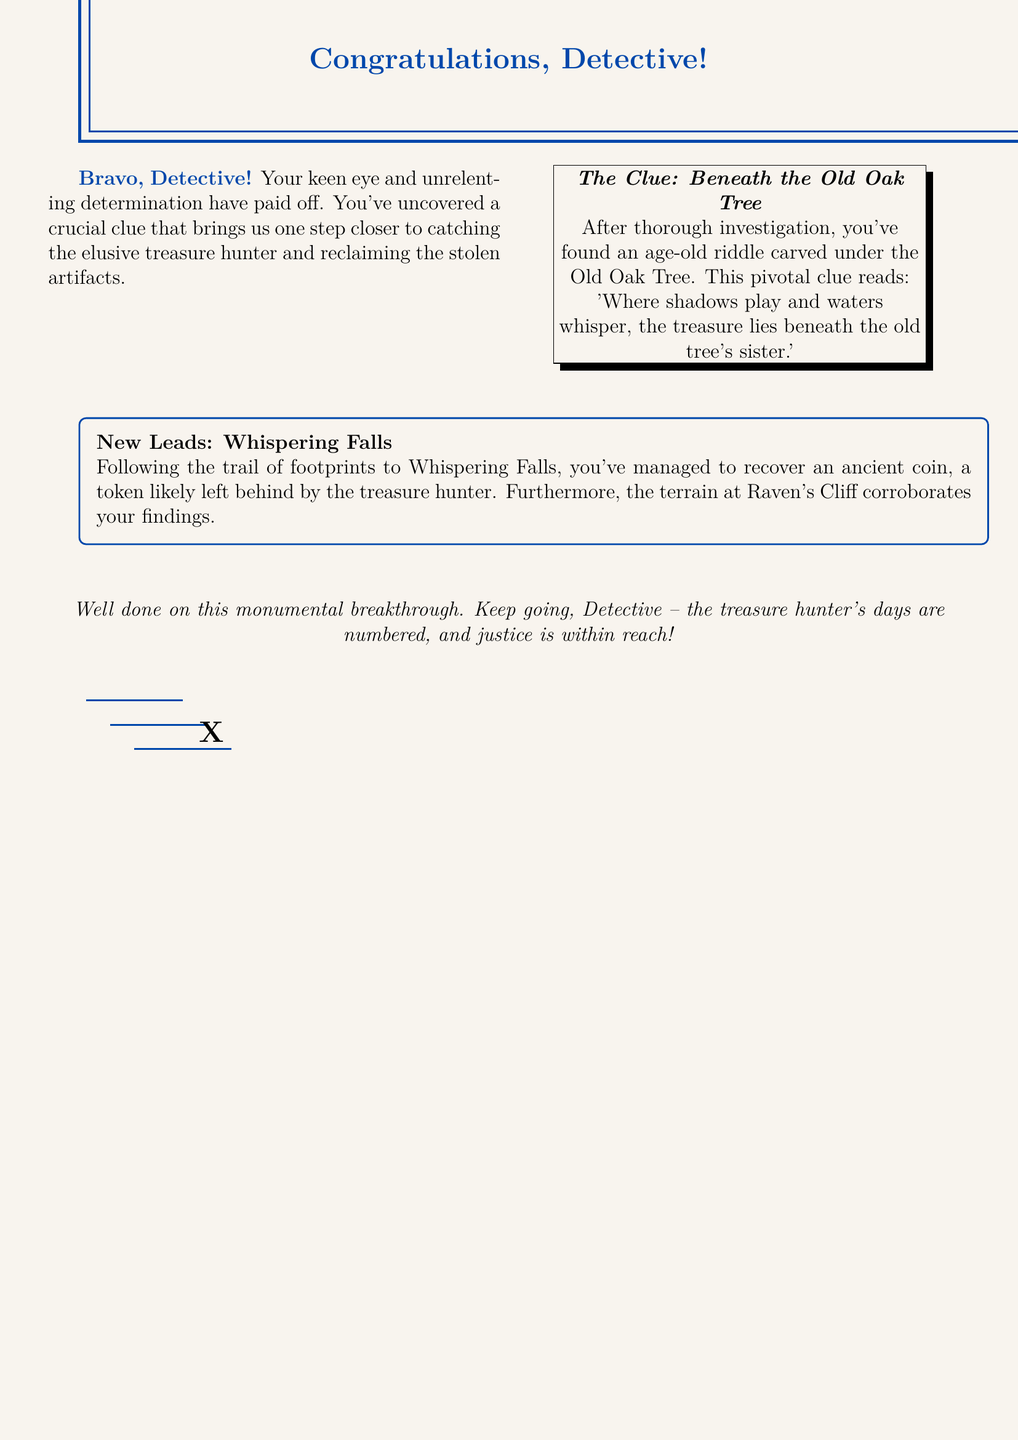What is the title of the card? The title of the card is prominently displayed at the top of the document, addressing the recipient.
Answer: Congratulations, Detective! What clue did the detective uncover? The document contains a specific riddle that the detective found under the Old Oak Tree, which is highlighted in the text.
Answer: Where shadows play and waters whisper, the treasure lies beneath the old tree's sister What is the next location mentioned in the treasure hunt? The document specifies a new place where the detective is directed to, following the clue.
Answer: Whispering Falls What item was recovered from Whispering Falls? The document indicates a specific artifact that was found during the investigation at Whispering Falls.
Answer: ancient coin What does the "X" symbolize in the card? The "X" visual at the bottom suggests the location of hidden treasure, traditionally marked on maps.
Answer: treasure What is the background color of the card? The overall background color of the document is described in the formatting and design choices.
Answer: mapbrown What is the purpose of the card? The card serves a specific function to congratulate and motivate the detective in their ongoing quest.
Answer: Celebratory note Who is the elusive target in the treasure hunt? The document refers to the individual being pursued by the detective throughout the narrative.
Answer: treasure hunter 